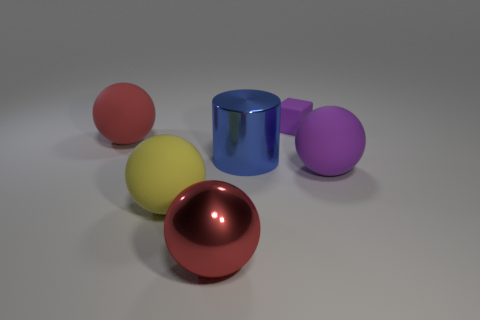Which object appears to be the most reflective, and how does that affect its appearance? The red sphere-like object appears to be the most reflective, with a bright highlight on its surface. Its reflective quality makes it stand out among the other objects, drawing attention and creating a sense of visual interest that contrasts with the more subdued reflections of the other objects. 